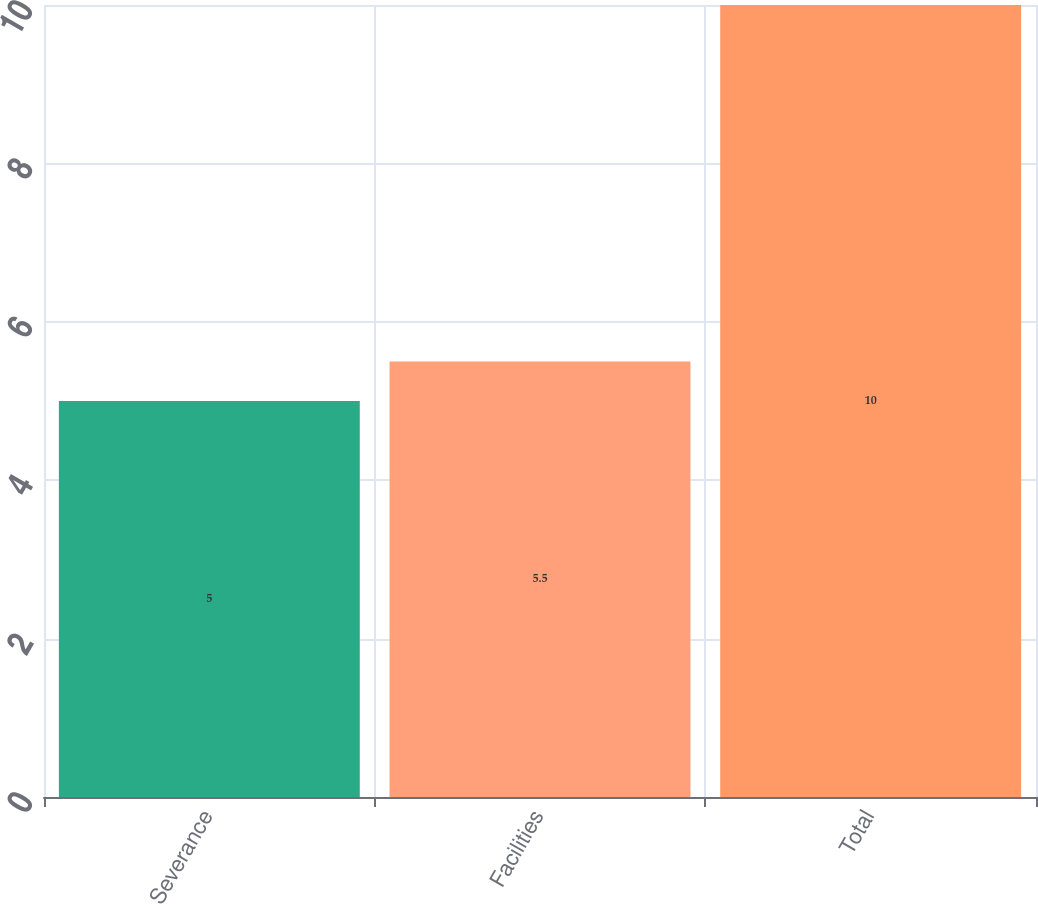Convert chart. <chart><loc_0><loc_0><loc_500><loc_500><bar_chart><fcel>Severance<fcel>Facilities<fcel>Total<nl><fcel>5<fcel>5.5<fcel>10<nl></chart> 